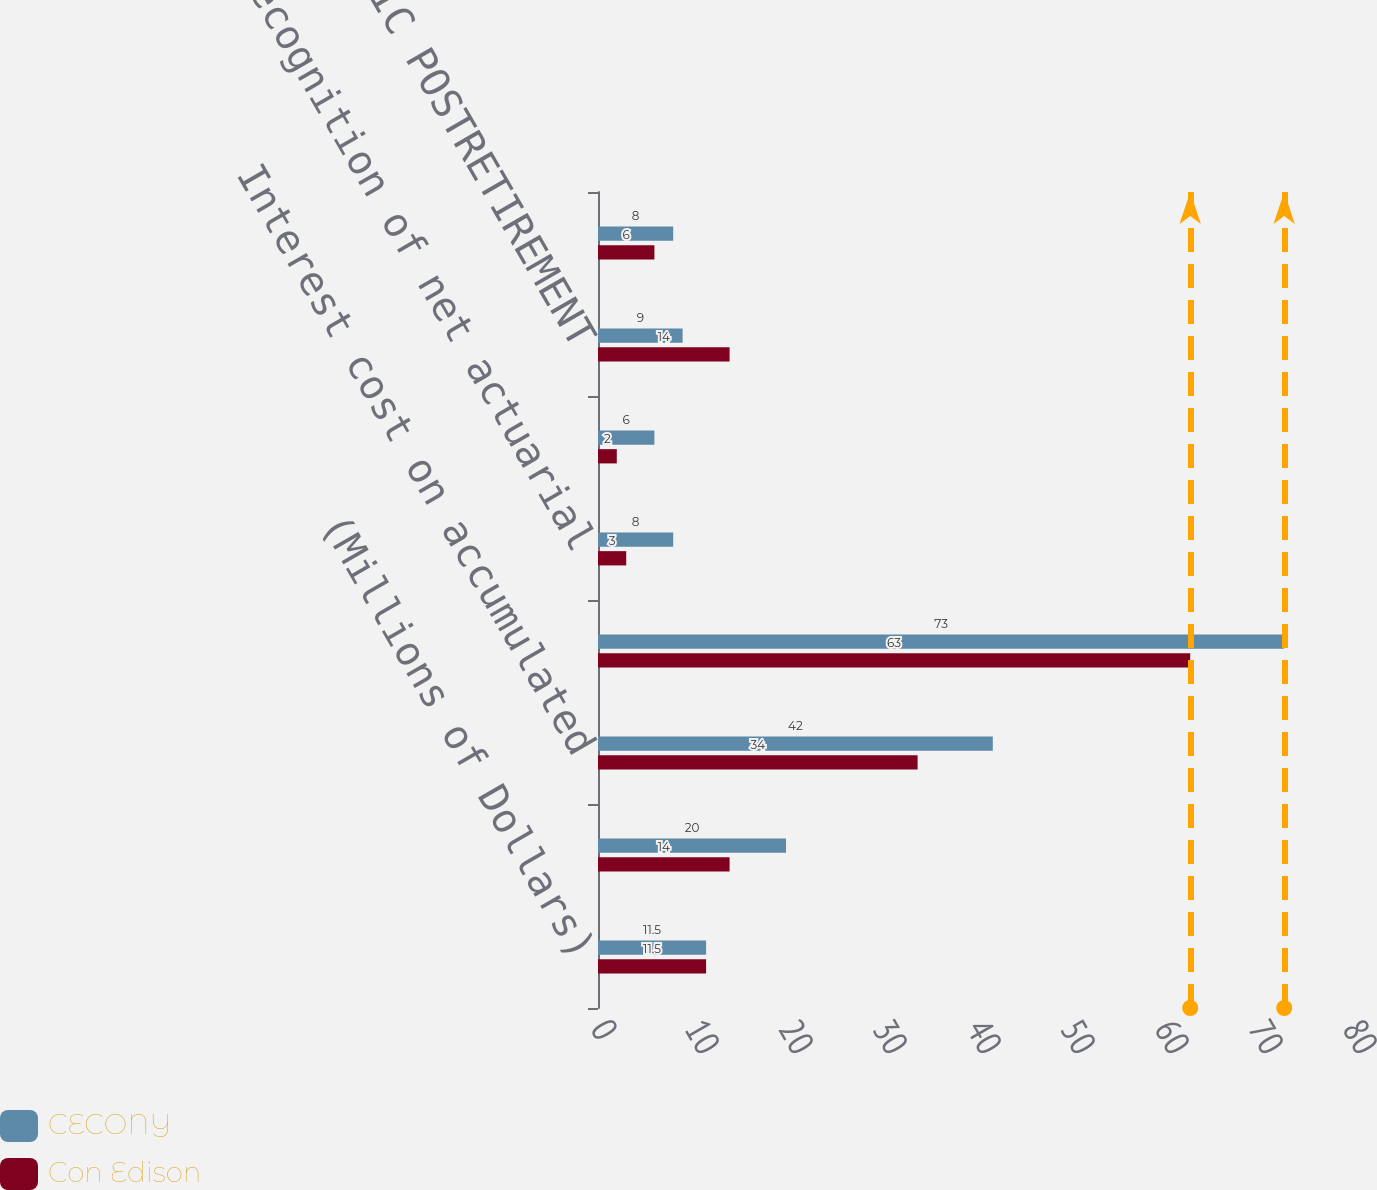<chart> <loc_0><loc_0><loc_500><loc_500><stacked_bar_chart><ecel><fcel>(Millions of Dollars)<fcel>Service cost<fcel>Interest cost on accumulated<fcel>Expected return on plan assets<fcel>Recognition of net actuarial<fcel>Recognition of prior service<fcel>TOTAL PERIODIC POSTRETIREMENT<fcel>Cost capitalized<nl><fcel>CECONY<fcel>11.5<fcel>20<fcel>42<fcel>73<fcel>8<fcel>6<fcel>9<fcel>8<nl><fcel>Con Edison<fcel>11.5<fcel>14<fcel>34<fcel>63<fcel>3<fcel>2<fcel>14<fcel>6<nl></chart> 